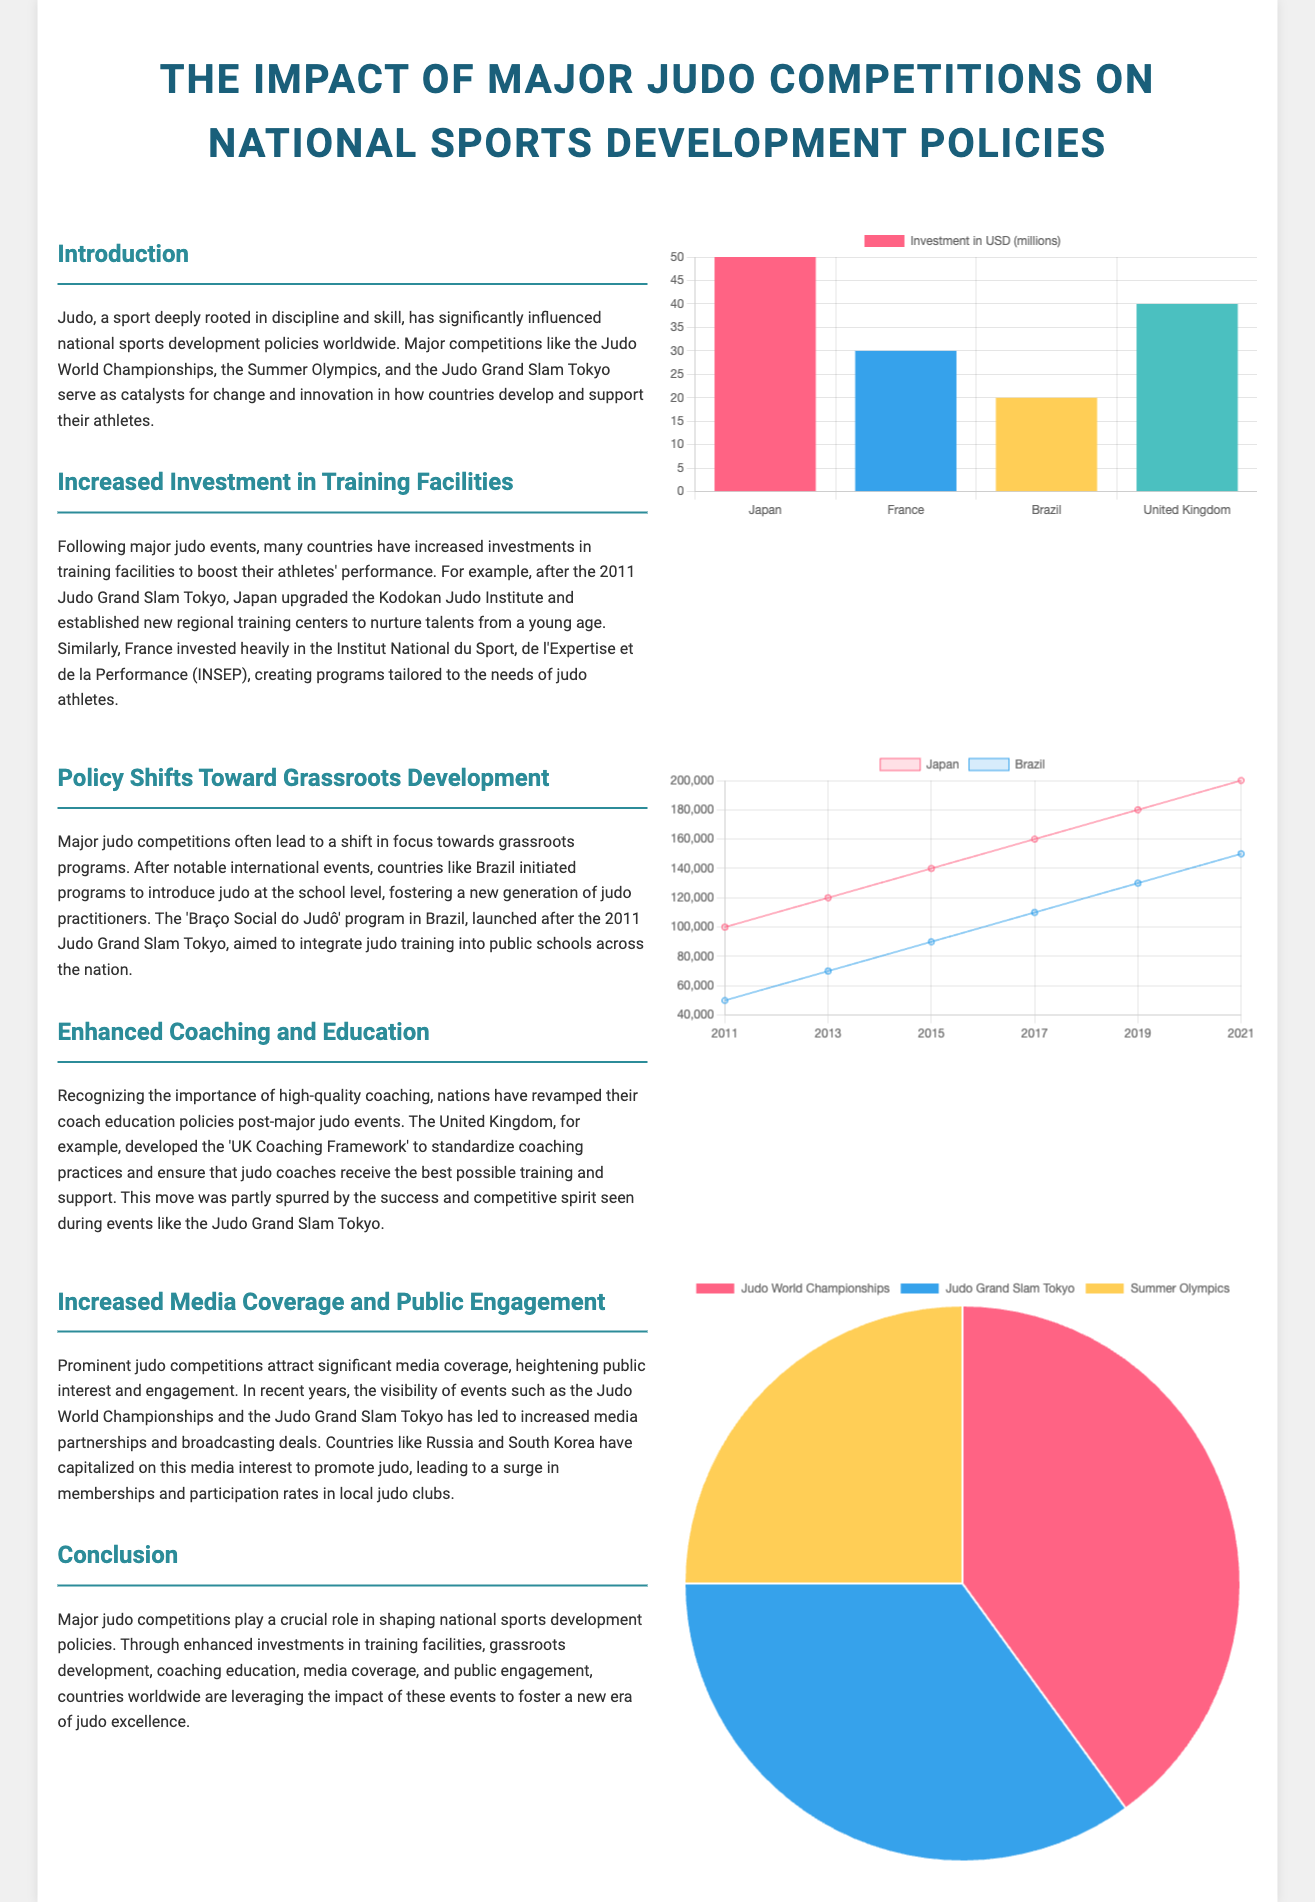What was the investment by Japan in training facilities post-2011? The investment by Japan in training facilities post-2011 is $50 million.
Answer: $50 million Which country invested in the Institut National du Sport, de l'Expertise et de la Performance? France invested in the Institut National du Sport, de l'Expertise et de la Performance.
Answer: France What grassroots program did Brazil launch after the 2011 Judo Grand Slam Tokyo? Brazil launched the 'Braço Social do Judô' program after the 2011 Judo Grand Slam Tokyo.
Answer: 'Braço Social do Judô' What was the youth judo participation in Japan in 2021? The youth judo participation in Japan in 2021 was 200,000.
Answer: 200,000 Which judo competition received the most media coverage according to the document? The Judo World Championships received the most media coverage according to the document.
Answer: Judo World Championships How many countries' investments are mentioned in the training facilities section? Four countries' investments are mentioned in the training facilities section.
Answer: Four What major judo competition is noted as influencing policy shifts? The 2011 Judo Grand Slam Tokyo is noted as influencing policy shifts.
Answer: 2011 Judo Grand Slam Tokyo Which chart type represents media coverage of major judo events? The chart type representing media coverage of major judo events is a pie chart.
Answer: Pie chart 